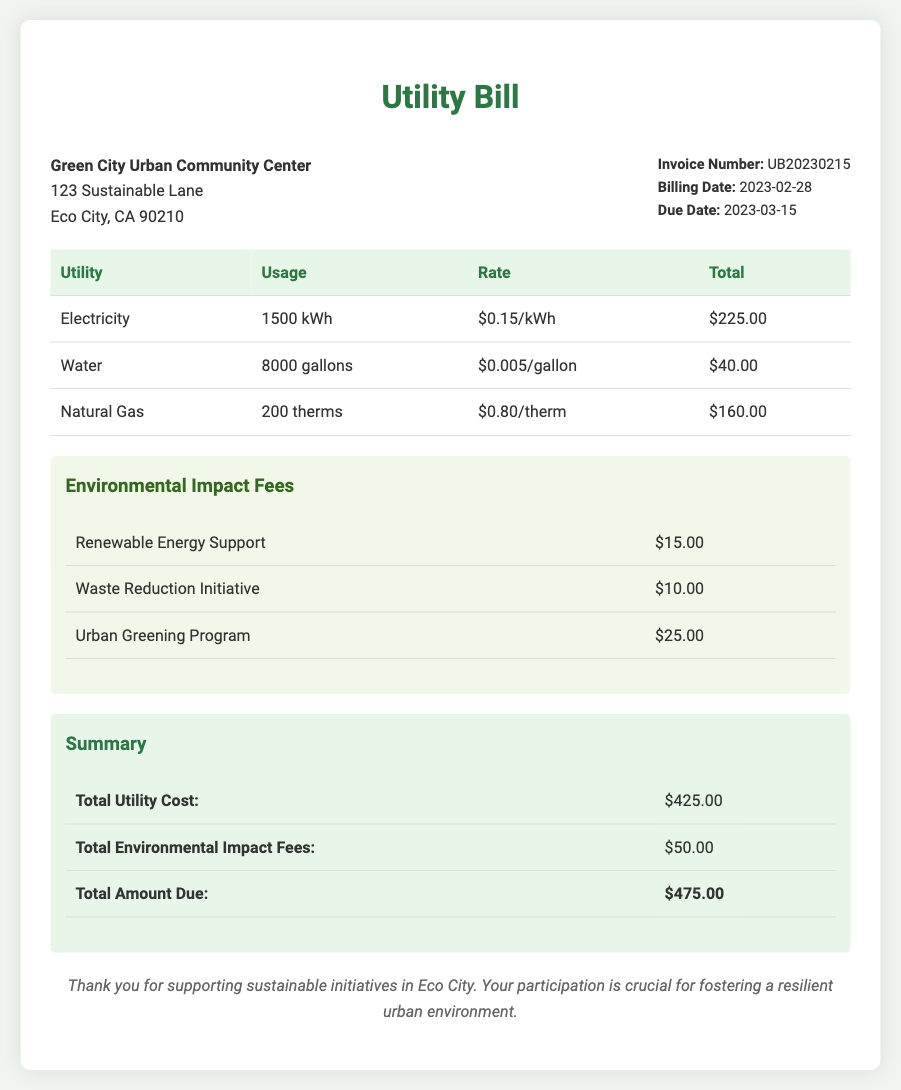What is the invoice number? The invoice number is indicated in the document as UB20230215.
Answer: UB20230215 What is the total utility cost? The total utility cost is stated in the summary section as $425.00.
Answer: $425.00 How much is charged for renewable energy support? The document specifies that renewable energy support fee is $15.00.
Answer: $15.00 When is the due date for the bill? The due date for the bill is provided as March 15, 2023.
Answer: 2023-03-15 What is the total amount due? The total amount due is listed as $475.00 in the summary table.
Answer: $475.00 How many gallons of water were used? The usage of water is recorded in the document as 8000 gallons.
Answer: 8000 gallons What is the total for environmental impact fees? The summary includes the total for environmental impact fees as $50.00.
Answer: $50.00 What is the billing date on the utility bill? The billing date is detailed in the document as February 28, 2023.
Answer: 2023-02-28 